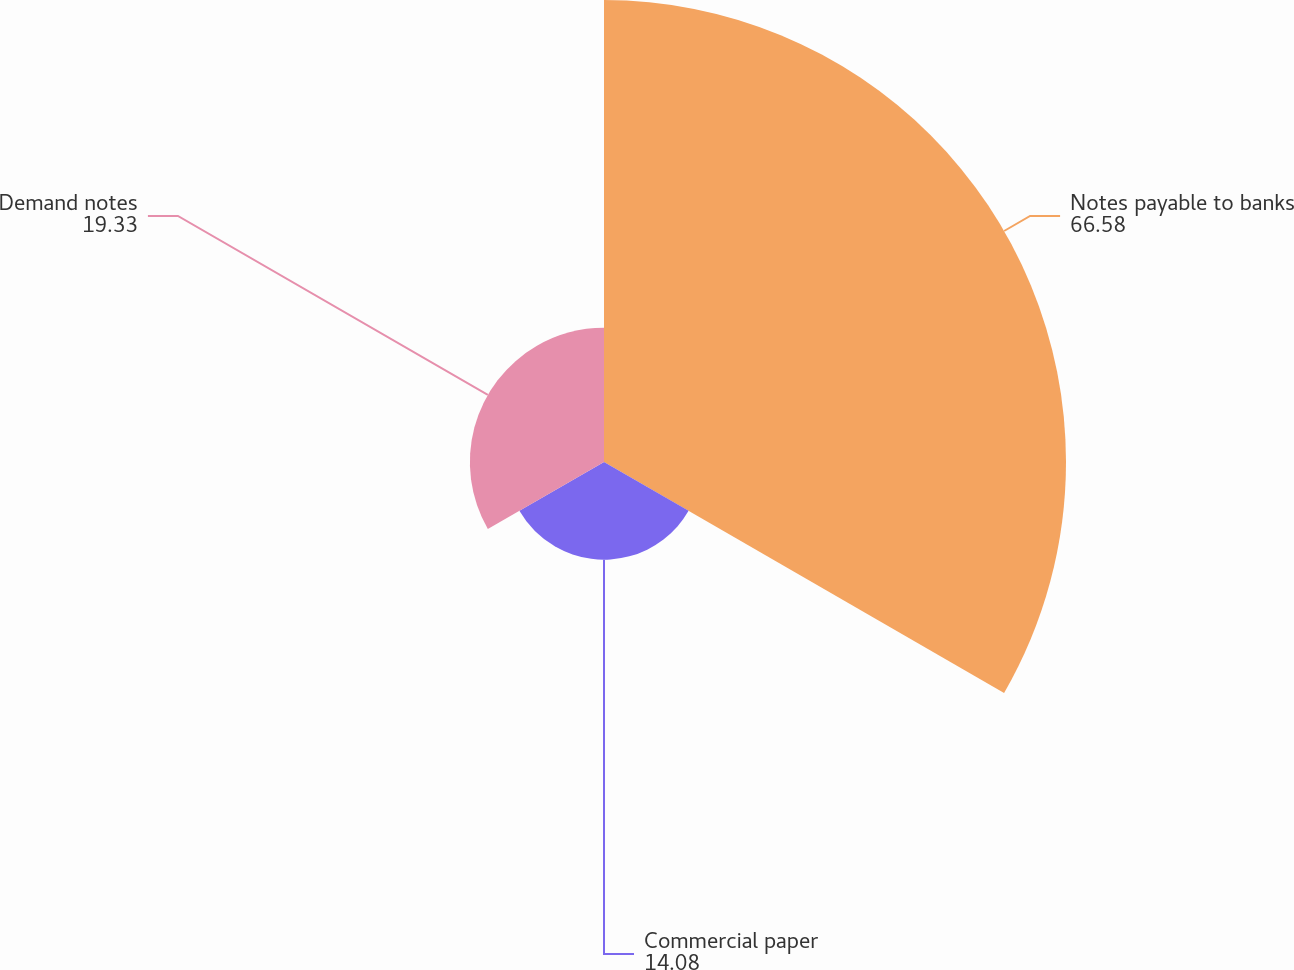Convert chart to OTSL. <chart><loc_0><loc_0><loc_500><loc_500><pie_chart><fcel>Notes payable to banks<fcel>Commercial paper<fcel>Demand notes<nl><fcel>66.58%<fcel>14.08%<fcel>19.33%<nl></chart> 